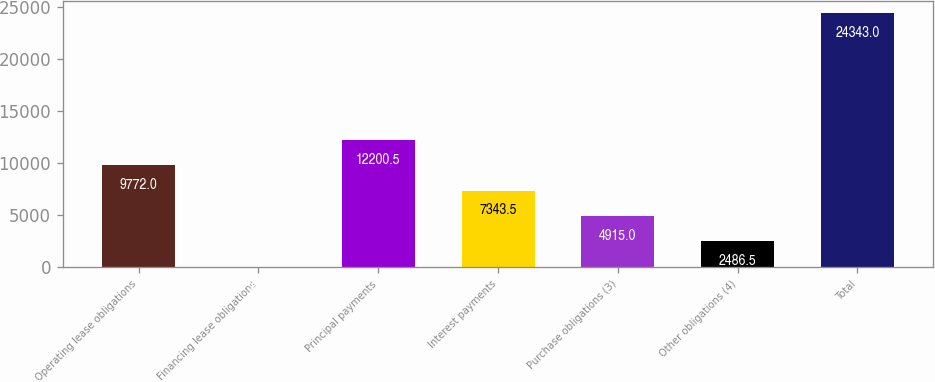Convert chart to OTSL. <chart><loc_0><loc_0><loc_500><loc_500><bar_chart><fcel>Operating lease obligations<fcel>Financing lease obligations<fcel>Principal payments<fcel>Interest payments<fcel>Purchase obligations (3)<fcel>Other obligations (4)<fcel>Total<nl><fcel>9772<fcel>58<fcel>12200.5<fcel>7343.5<fcel>4915<fcel>2486.5<fcel>24343<nl></chart> 